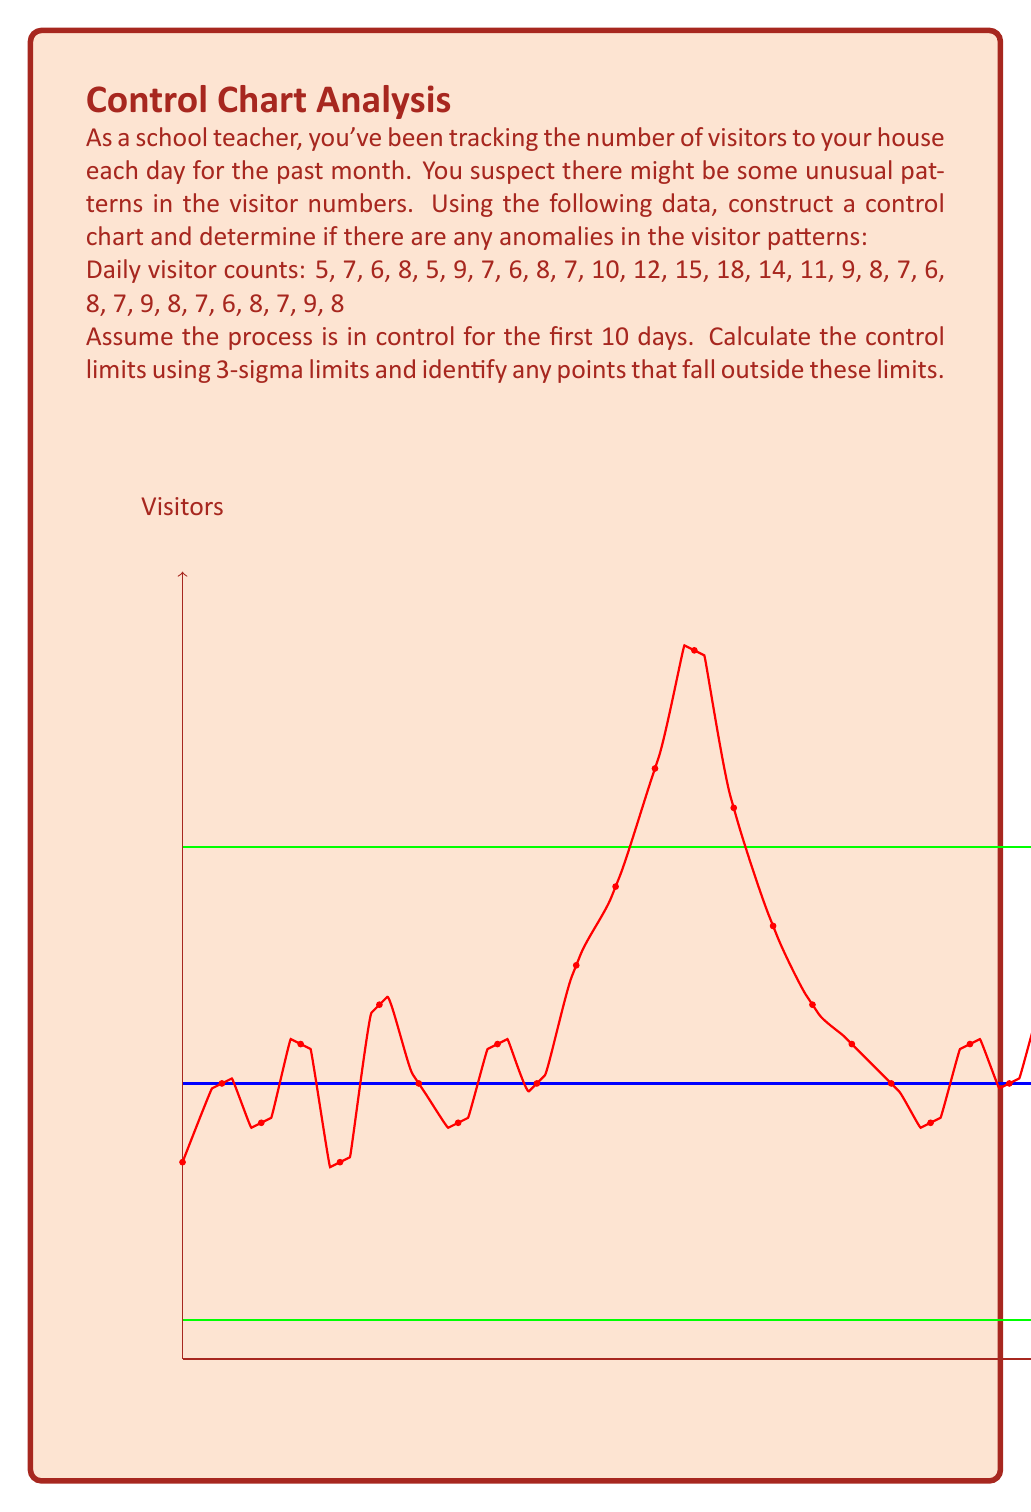Teach me how to tackle this problem. To solve this problem, we'll follow these steps:

1) Calculate the mean ($\bar{x}$) and standard deviation ($s$) of the first 10 data points:

   $\bar{x} = \frac{5 + 7 + 6 + 8 + 5 + 9 + 7 + 6 + 8 + 7}{10} = 6.8$

   $s = \sqrt{\frac{\sum_{i=1}^{10} (x_i - \bar{x})^2}{9}} = 1.317$

2) Calculate the Upper Control Limit (UCL) and Lower Control Limit (LCL):

   $UCL = \bar{x} + 3s = 6.8 + 3(1.317) = 10.751$
   $LCL = \bar{x} - 3s = 6.8 - 3(1.317) = 2.849$

3) Identify points outside the control limits:

   Examining the data, we find:
   - Day 13: 15 visitors (above UCL)
   - Day 14: 18 visitors (above UCL)
   - Day 15: 14 visitors (above UCL)

4) Interpret the results:

   The control chart shows three consecutive points (days 13-15) above the Upper Control Limit. This indicates an anomaly in the visitor pattern, suggesting an unusual increase in visitors during this period.

In statistical process control, this pattern is often referred to as a "run" or "trend" and is considered a strong indication that the process is out of control or that there has been a significant shift in the underlying process.
Answer: Anomaly detected: 3 consecutive points (days 13-15) above UCL (10.751). 